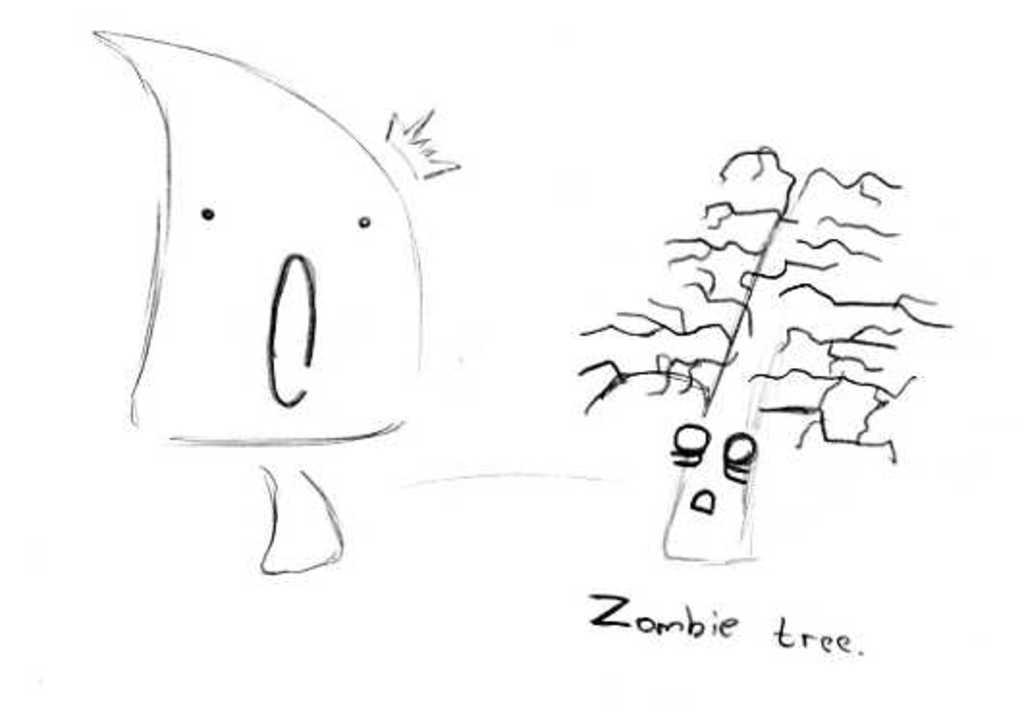What can be seen in the image? There are two drawings in the image. What are the drawings labeled as? The drawings are labeled as 'Zombie tree'. What color is the background of the image? The background of the image is white. What type of flowers can be seen growing near the zombie tree in the image? There are no flowers present in the image; it only features two drawings labeled as 'Zombie tree' on a white background. 